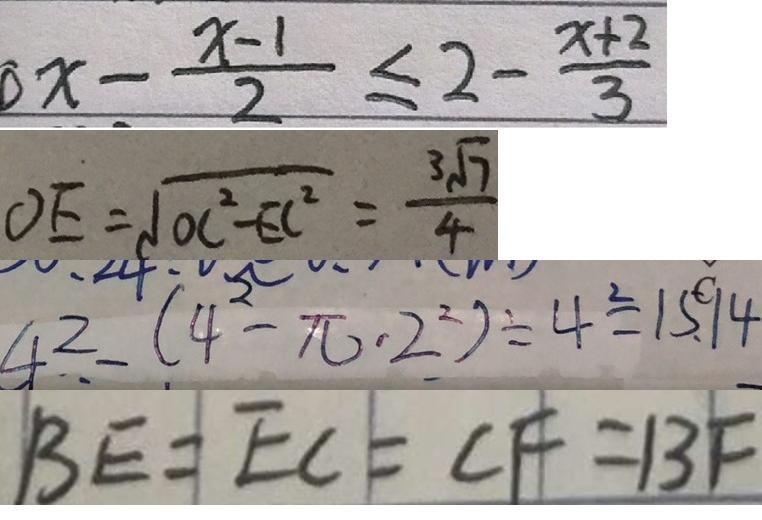Convert formula to latex. <formula><loc_0><loc_0><loc_500><loc_500>x - \frac { x - 1 } { 2 } \leq 2 - \frac { x + 2 } { 3 } 
 O E = \sqrt { O C ^ { 2 } - E C ^ { 2 } } = \frac { 3 \sqrt { 7 } } { 4 } 
 4 ^ { 2 } - ( 4 ^ { 2 } - \pi \cdot 2 ^ { 2 } ) \div 4 ^ { 2 } = 1 5 . 1 4 
 B E = E C = C F = B F</formula> 